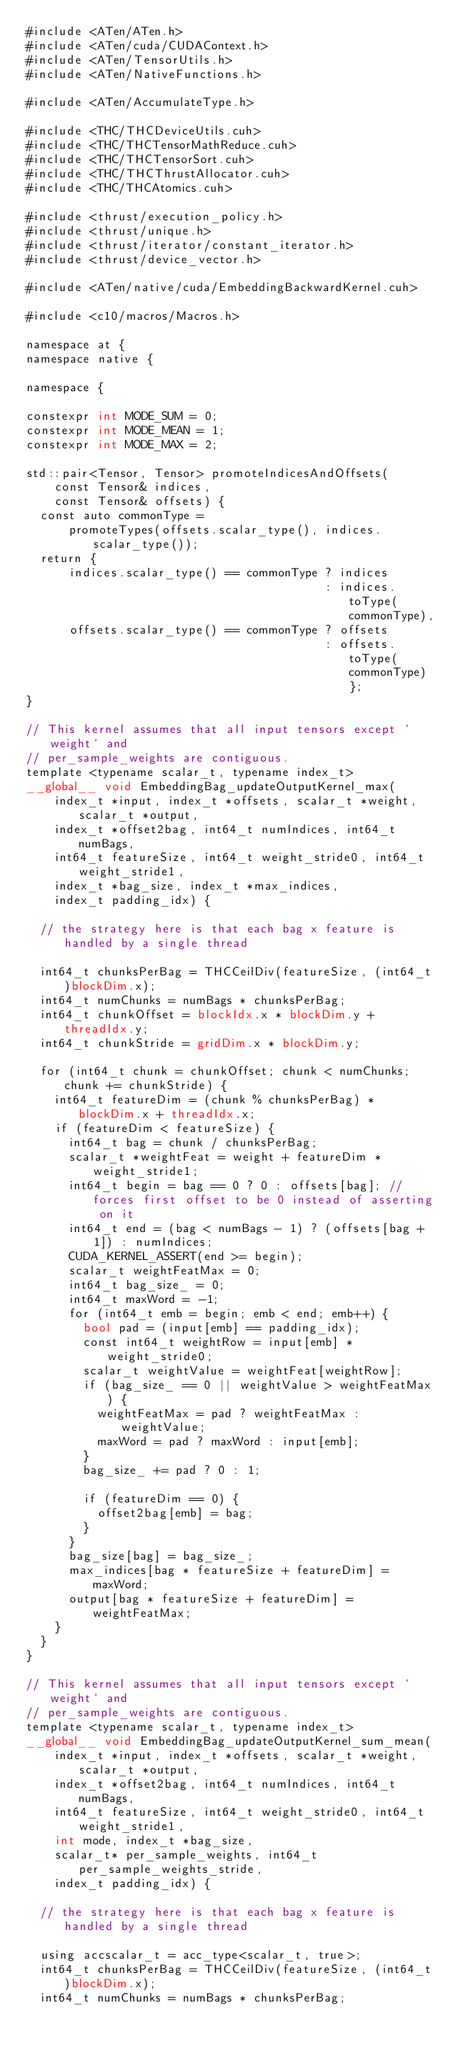Convert code to text. <code><loc_0><loc_0><loc_500><loc_500><_Cuda_>#include <ATen/ATen.h>
#include <ATen/cuda/CUDAContext.h>
#include <ATen/TensorUtils.h>
#include <ATen/NativeFunctions.h>

#include <ATen/AccumulateType.h>

#include <THC/THCDeviceUtils.cuh>
#include <THC/THCTensorMathReduce.cuh>
#include <THC/THCTensorSort.cuh>
#include <THC/THCThrustAllocator.cuh>
#include <THC/THCAtomics.cuh>

#include <thrust/execution_policy.h>
#include <thrust/unique.h>
#include <thrust/iterator/constant_iterator.h>
#include <thrust/device_vector.h>

#include <ATen/native/cuda/EmbeddingBackwardKernel.cuh>

#include <c10/macros/Macros.h>

namespace at {
namespace native {

namespace {

constexpr int MODE_SUM = 0;
constexpr int MODE_MEAN = 1;
constexpr int MODE_MAX = 2;

std::pair<Tensor, Tensor> promoteIndicesAndOffsets(
    const Tensor& indices,
    const Tensor& offsets) {
  const auto commonType =
      promoteTypes(offsets.scalar_type(), indices.scalar_type());
  return {
      indices.scalar_type() == commonType ? indices
                                          : indices.toType(commonType),
      offsets.scalar_type() == commonType ? offsets
                                          : offsets.toType(commonType)};
}

// This kernel assumes that all input tensors except `weight` and
// per_sample_weights are contiguous.
template <typename scalar_t, typename index_t>
__global__ void EmbeddingBag_updateOutputKernel_max(
    index_t *input, index_t *offsets, scalar_t *weight, scalar_t *output,
    index_t *offset2bag, int64_t numIndices, int64_t numBags,
    int64_t featureSize, int64_t weight_stride0, int64_t weight_stride1,
    index_t *bag_size, index_t *max_indices,
    index_t padding_idx) {

  // the strategy here is that each bag x feature is handled by a single thread

  int64_t chunksPerBag = THCCeilDiv(featureSize, (int64_t)blockDim.x);
  int64_t numChunks = numBags * chunksPerBag;
  int64_t chunkOffset = blockIdx.x * blockDim.y + threadIdx.y;
  int64_t chunkStride = gridDim.x * blockDim.y;

  for (int64_t chunk = chunkOffset; chunk < numChunks; chunk += chunkStride) {
    int64_t featureDim = (chunk % chunksPerBag) * blockDim.x + threadIdx.x;
    if (featureDim < featureSize) {
      int64_t bag = chunk / chunksPerBag;
      scalar_t *weightFeat = weight + featureDim * weight_stride1;
      int64_t begin = bag == 0 ? 0 : offsets[bag]; // forces first offset to be 0 instead of asserting on it
      int64_t end = (bag < numBags - 1) ? (offsets[bag + 1]) : numIndices;
      CUDA_KERNEL_ASSERT(end >= begin);
      scalar_t weightFeatMax = 0;
      int64_t bag_size_ = 0;
      int64_t maxWord = -1;
      for (int64_t emb = begin; emb < end; emb++) {
        bool pad = (input[emb] == padding_idx);
        const int64_t weightRow = input[emb] * weight_stride0;
        scalar_t weightValue = weightFeat[weightRow];
        if (bag_size_ == 0 || weightValue > weightFeatMax) {
          weightFeatMax = pad ? weightFeatMax : weightValue;
          maxWord = pad ? maxWord : input[emb];
        }
        bag_size_ += pad ? 0 : 1;

        if (featureDim == 0) {
          offset2bag[emb] = bag;
        }
      }
      bag_size[bag] = bag_size_;
      max_indices[bag * featureSize + featureDim] = maxWord;
      output[bag * featureSize + featureDim] = weightFeatMax;
    }
  }
}

// This kernel assumes that all input tensors except `weight` and
// per_sample_weights are contiguous.
template <typename scalar_t, typename index_t>
__global__ void EmbeddingBag_updateOutputKernel_sum_mean(
    index_t *input, index_t *offsets, scalar_t *weight, scalar_t *output,
    index_t *offset2bag, int64_t numIndices, int64_t numBags,
    int64_t featureSize, int64_t weight_stride0, int64_t weight_stride1,
    int mode, index_t *bag_size,
    scalar_t* per_sample_weights, int64_t per_sample_weights_stride,
    index_t padding_idx) {

  // the strategy here is that each bag x feature is handled by a single thread

  using accscalar_t = acc_type<scalar_t, true>;
  int64_t chunksPerBag = THCCeilDiv(featureSize, (int64_t)blockDim.x);
  int64_t numChunks = numBags * chunksPerBag;</code> 